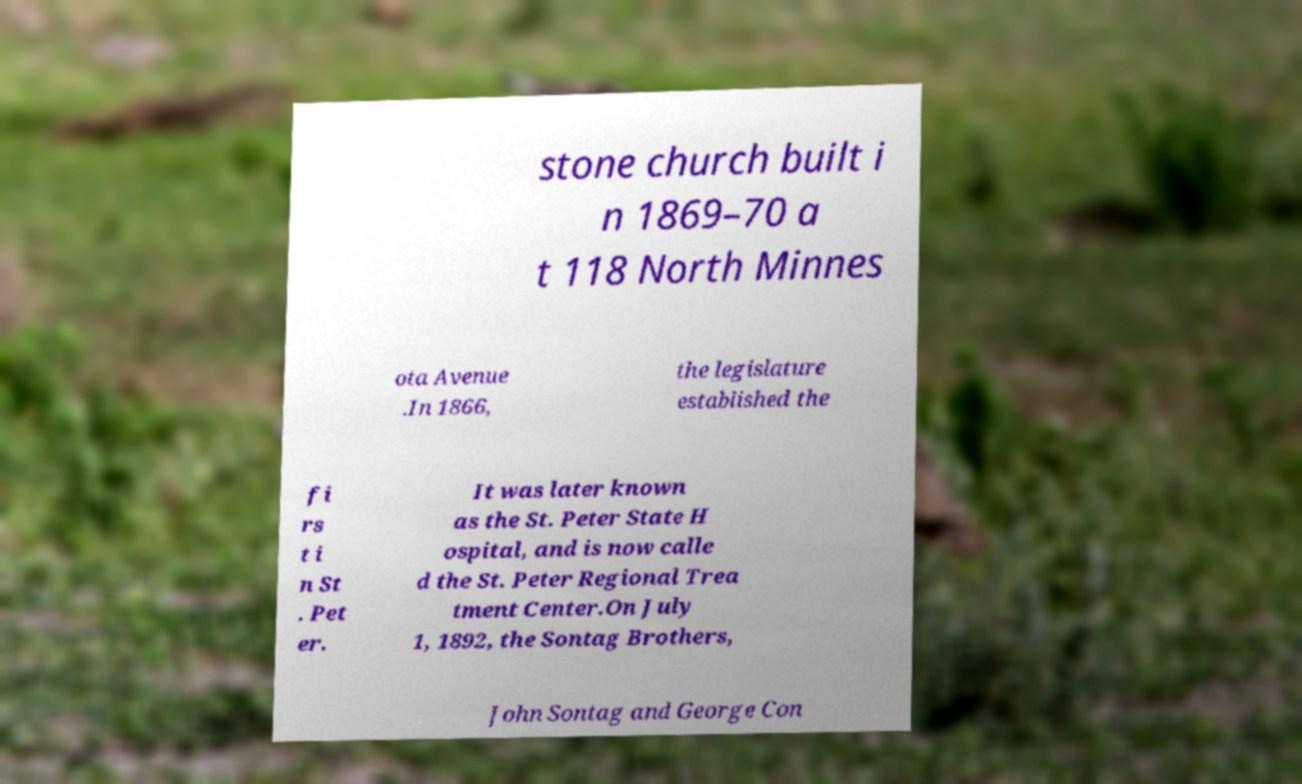What messages or text are displayed in this image? I need them in a readable, typed format. stone church built i n 1869–70 a t 118 North Minnes ota Avenue .In 1866, the legislature established the fi rs t i n St . Pet er. It was later known as the St. Peter State H ospital, and is now calle d the St. Peter Regional Trea tment Center.On July 1, 1892, the Sontag Brothers, John Sontag and George Con 